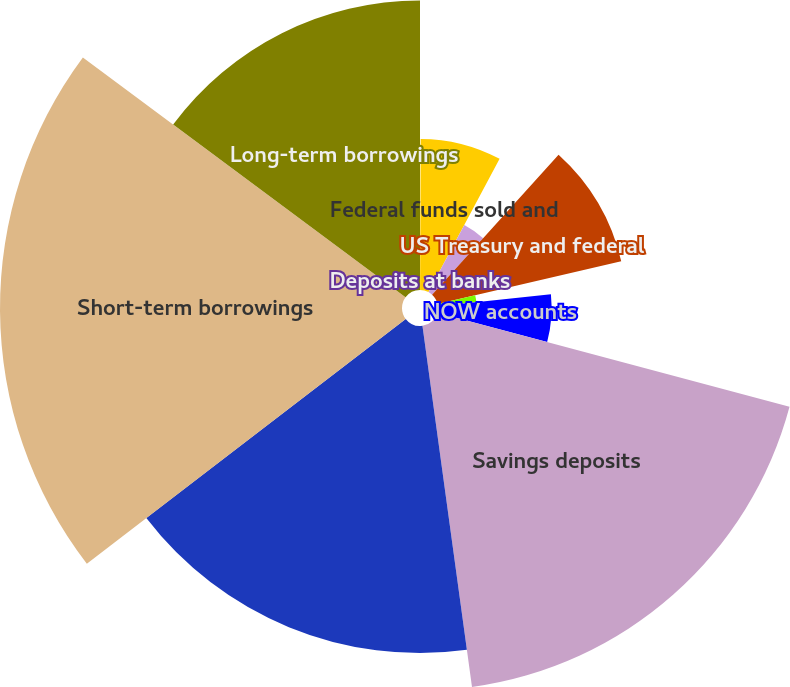Convert chart. <chart><loc_0><loc_0><loc_500><loc_500><pie_chart><fcel>Deposits at banks<fcel>Federal funds sold and<fcel>Trading account<fcel>US Treasury and federal<fcel>Obligations of states and<fcel>NOW accounts<fcel>Savings deposits<fcel>Deposits at foreign office<fcel>Short-term borrowings<fcel>Long-term borrowings<nl><fcel>0.06%<fcel>7.74%<fcel>3.9%<fcel>9.66%<fcel>1.98%<fcel>5.82%<fcel>18.67%<fcel>16.75%<fcel>20.59%<fcel>14.83%<nl></chart> 